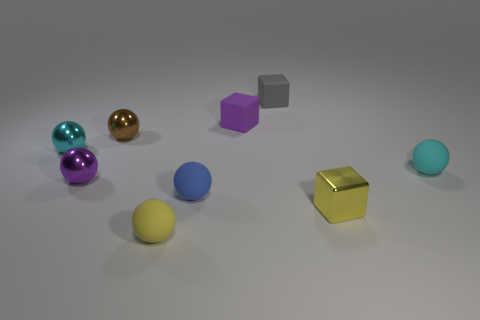Subtract all tiny purple rubber cubes. How many cubes are left? 2 Subtract all yellow blocks. How many blocks are left? 2 Subtract all cubes. How many objects are left? 6 Subtract 3 balls. How many balls are left? 3 Subtract all brown blocks. Subtract all cyan cylinders. How many blocks are left? 3 Subtract all gray balls. How many purple blocks are left? 1 Subtract all tiny red matte balls. Subtract all blue matte spheres. How many objects are left? 8 Add 7 brown shiny objects. How many brown shiny objects are left? 8 Add 4 cyan things. How many cyan things exist? 6 Subtract 1 purple balls. How many objects are left? 8 